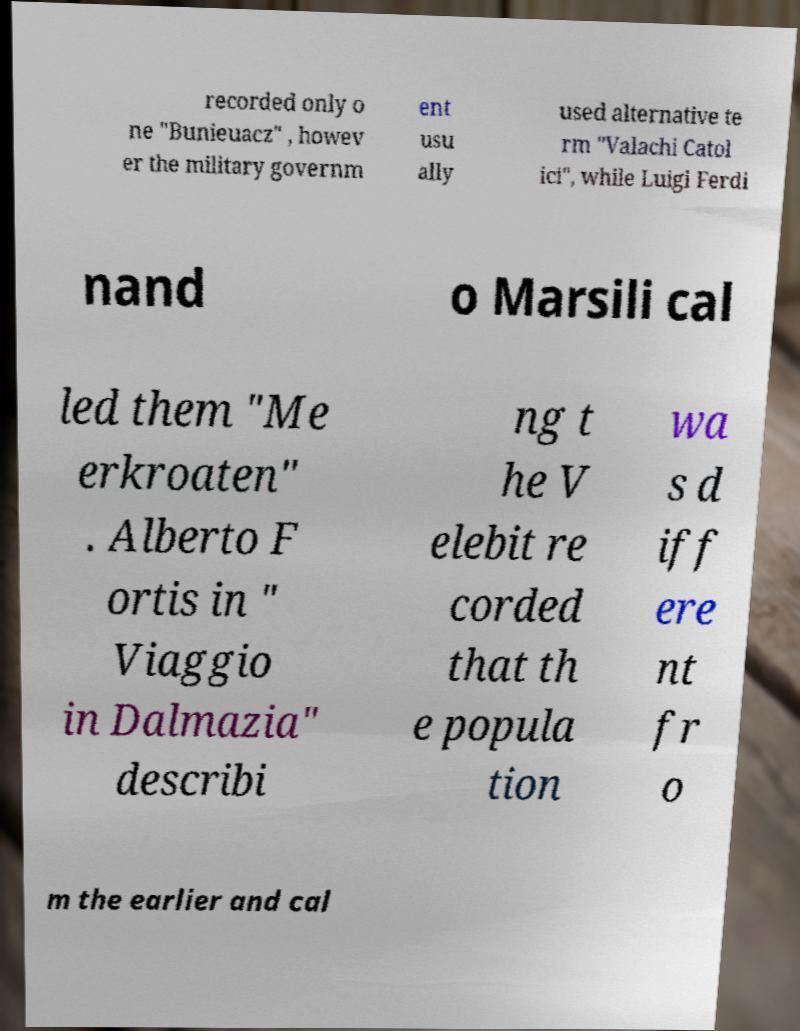Please identify and transcribe the text found in this image. recorded only o ne "Bunieuacz" , howev er the military governm ent usu ally used alternative te rm "Valachi Catol ici", while Luigi Ferdi nand o Marsili cal led them "Me erkroaten" . Alberto F ortis in " Viaggio in Dalmazia" describi ng t he V elebit re corded that th e popula tion wa s d iff ere nt fr o m the earlier and cal 